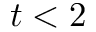<formula> <loc_0><loc_0><loc_500><loc_500>t < 2</formula> 